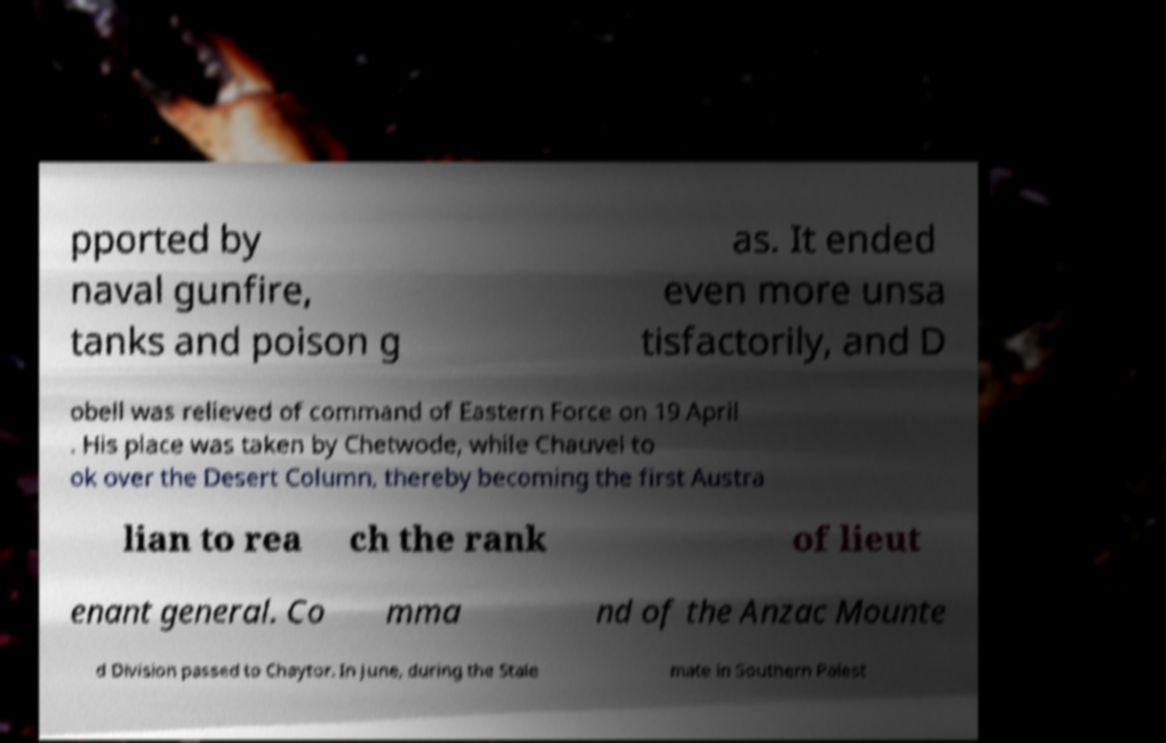What messages or text are displayed in this image? I need them in a readable, typed format. pported by naval gunfire, tanks and poison g as. It ended even more unsa tisfactorily, and D obell was relieved of command of Eastern Force on 19 April . His place was taken by Chetwode, while Chauvel to ok over the Desert Column, thereby becoming the first Austra lian to rea ch the rank of lieut enant general. Co mma nd of the Anzac Mounte d Division passed to Chaytor. In June, during the Stale mate in Southern Palest 